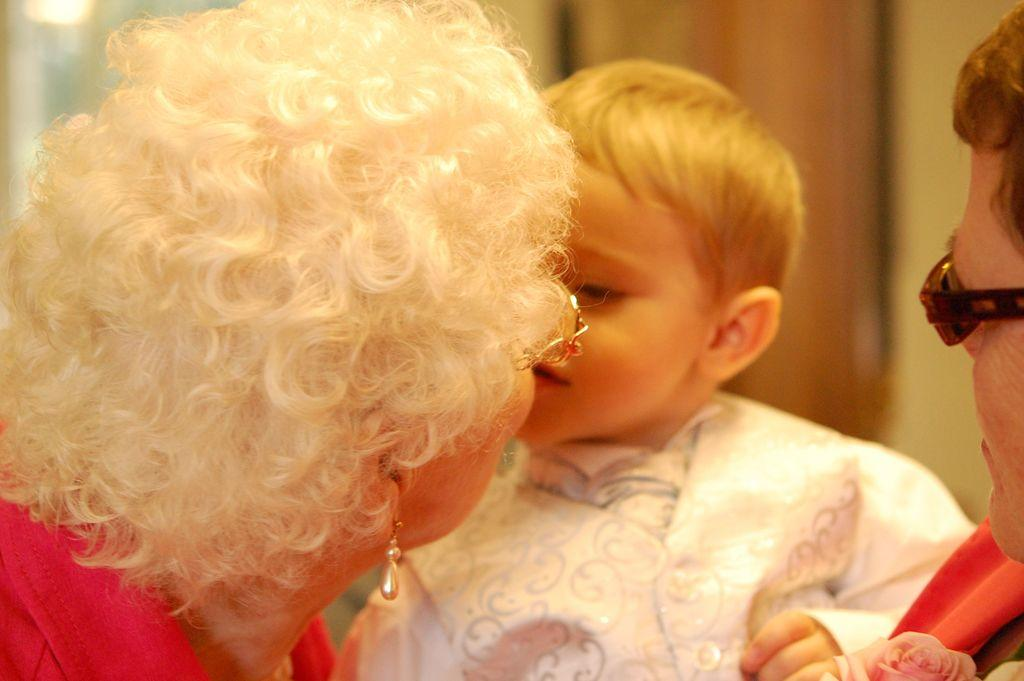Who is the main subject in the image? There is an old woman in the image. What is the old woman doing in the image? The old woman is kissing a kid. Are there any other people in the image? Yes, there is a person standing in the image. What is the person doing in the image? The person is holding a kid. How would you describe the background of the image? The background of the image is blurred. What channel is the old woman watching on the TV in the image? There is no TV present in the image, so it is not possible to determine what channel the old woman might be watching. 